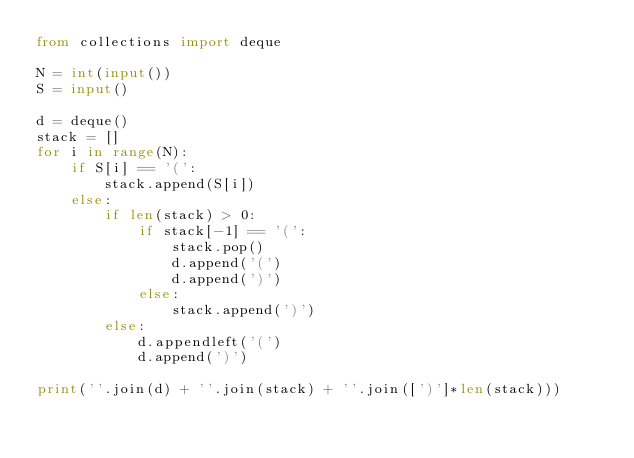Convert code to text. <code><loc_0><loc_0><loc_500><loc_500><_Python_>from collections import deque

N = int(input())
S = input()

d = deque()
stack = []
for i in range(N):
    if S[i] == '(':
        stack.append(S[i])
    else:
        if len(stack) > 0:
            if stack[-1] == '(':
                stack.pop()
                d.append('(')
                d.append(')')
            else:
                stack.append(')')
        else:
            d.appendleft('(')
            d.append(')')
  
print(''.join(d) + ''.join(stack) + ''.join([')']*len(stack)))
</code> 